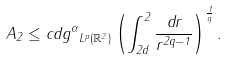Convert formula to latex. <formula><loc_0><loc_0><loc_500><loc_500>A _ { 2 } \leq c d \| g ^ { \alpha } \| _ { L ^ { p } ( \mathbb { R } ^ { 2 } ) } \left ( \int _ { 2 d } ^ { 2 } \frac { \, d r } { r ^ { 2 q - 1 } } \right ) ^ { \frac { 1 } { q } } .</formula> 